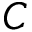Convert formula to latex. <formula><loc_0><loc_0><loc_500><loc_500>C</formula> 